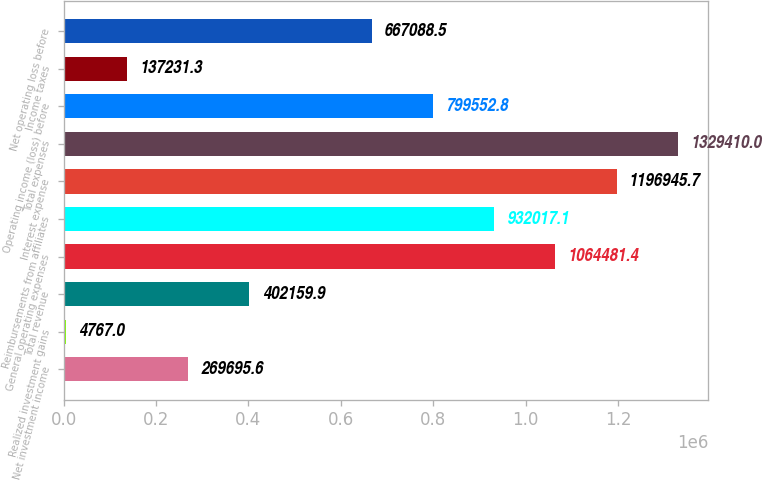Convert chart. <chart><loc_0><loc_0><loc_500><loc_500><bar_chart><fcel>Net investment income<fcel>Realized investment gains<fcel>Total revenue<fcel>General operating expenses<fcel>Reimbursements from affiliates<fcel>Interest expense<fcel>Total expenses<fcel>Operating income (loss) before<fcel>Income taxes<fcel>Net operating loss before<nl><fcel>269696<fcel>4767<fcel>402160<fcel>1.06448e+06<fcel>932017<fcel>1.19695e+06<fcel>1.32941e+06<fcel>799553<fcel>137231<fcel>667088<nl></chart> 